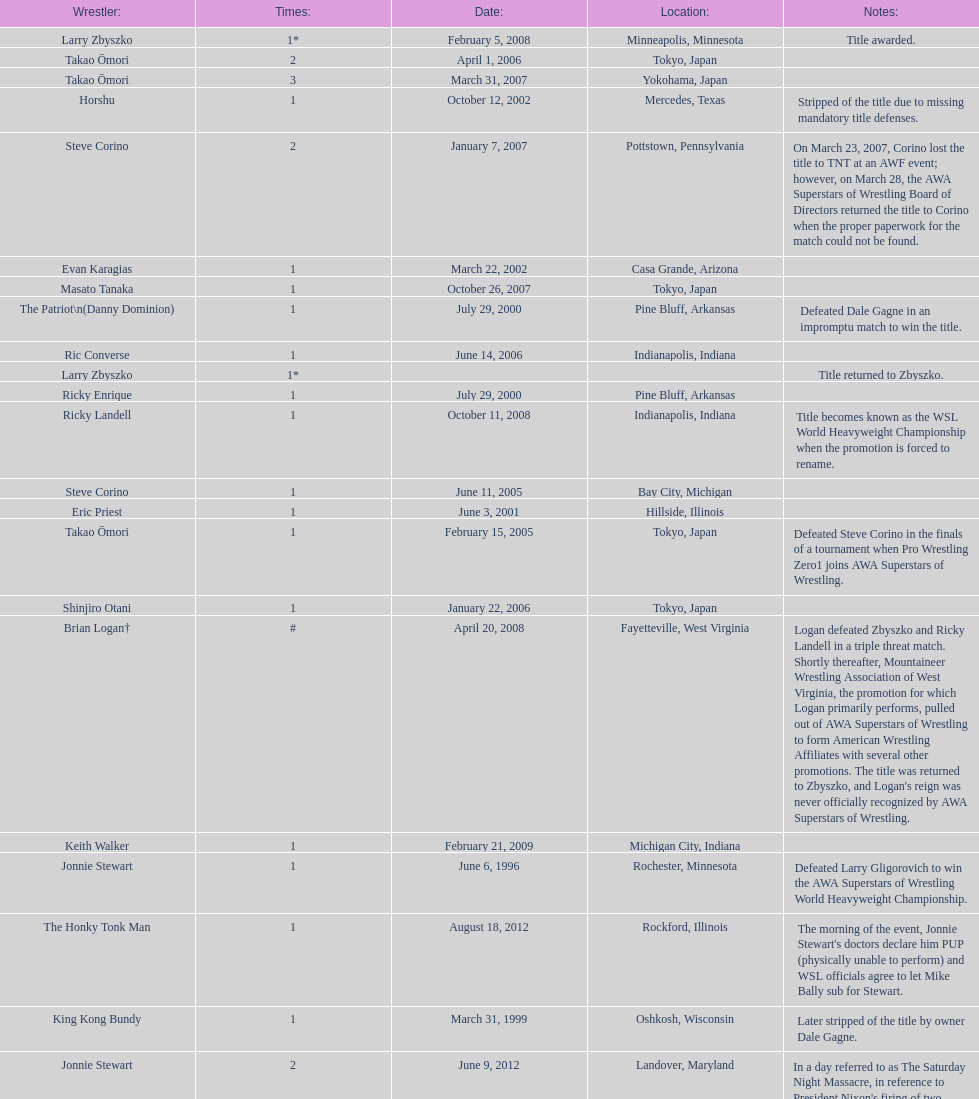Who is the only wsl title holder from texas? Horshu. 